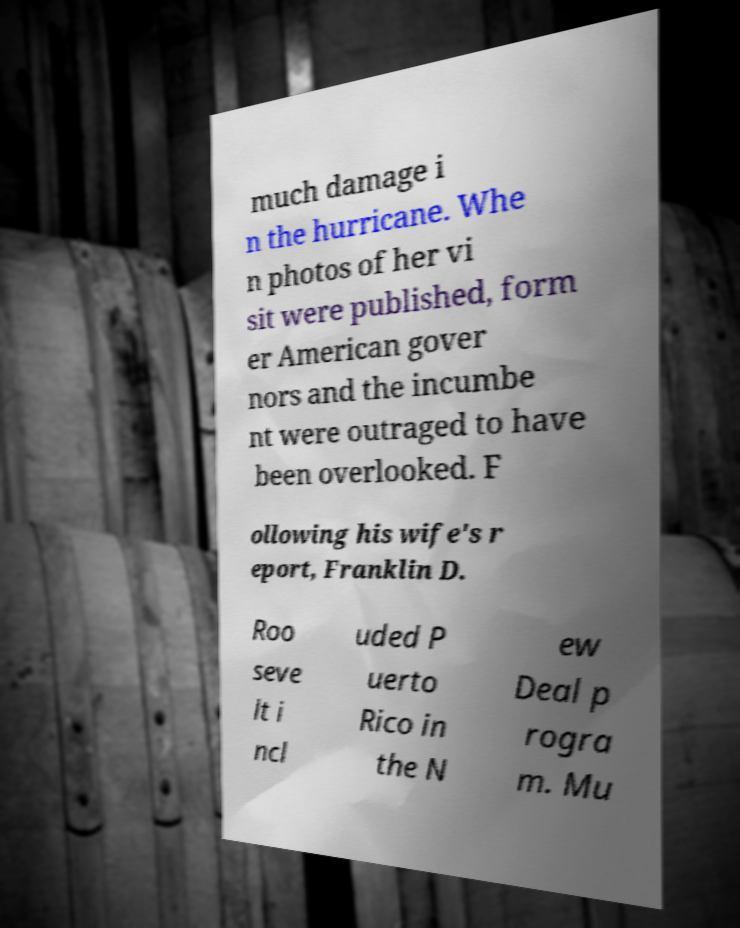Can you read and provide the text displayed in the image?This photo seems to have some interesting text. Can you extract and type it out for me? much damage i n the hurricane. Whe n photos of her vi sit were published, form er American gover nors and the incumbe nt were outraged to have been overlooked. F ollowing his wife's r eport, Franklin D. Roo seve lt i ncl uded P uerto Rico in the N ew Deal p rogra m. Mu 